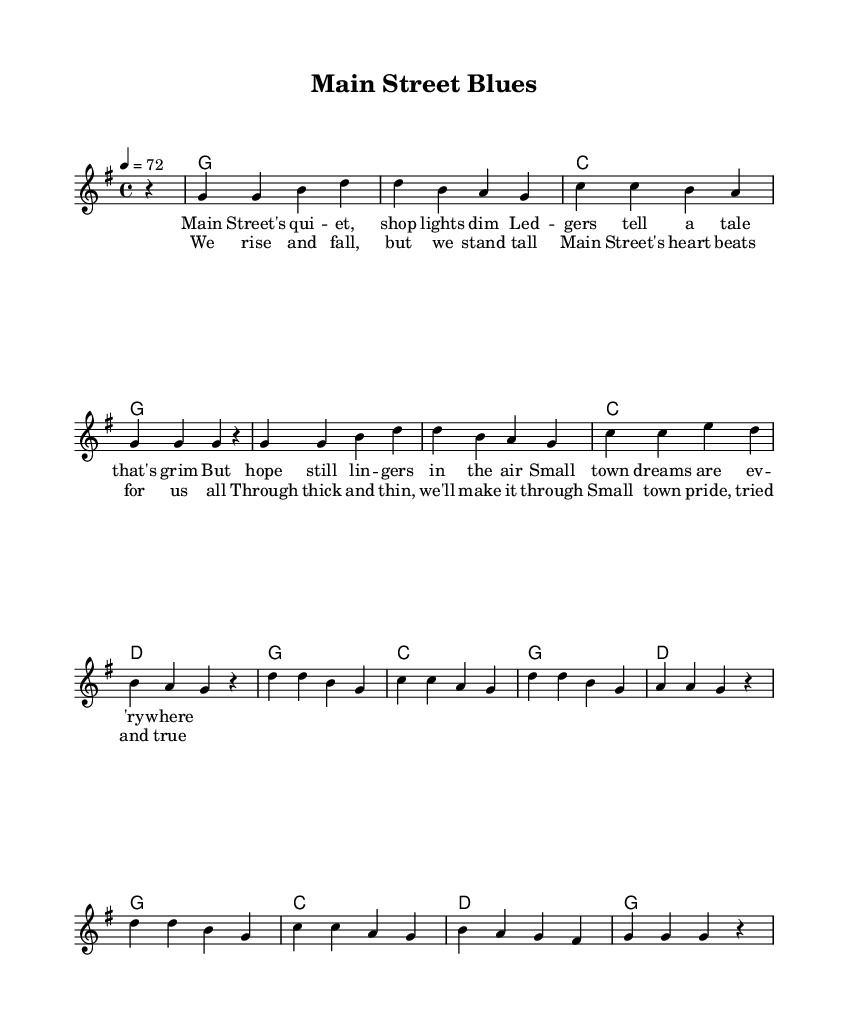What is the key signature of this music? The key signature of the music is G major, which has one sharp (F#). This can be determined by looking at the key indication at the beginning of the score.
Answer: G major What is the time signature of this music? The time signature is four-four, indicated by "4/4" at the beginning of the piece. This means there are four beats in each measure.
Answer: Four-four What is the tempo marking of the music? The tempo marking is quarter note equals 72, shown at the beginning of the score as "4 = 72." This indication tells the performer the pace at which to play the piece.
Answer: Quarter note equals 72 Which section features the lyrics about small-town pride? The lyrics that reference small-town pride are found in the chorus, as they emphasize standing strong and being "tried and true."
Answer: Chorus How many measures are in the verse section? The verse section contains eight measures, which can be counted by looking at the notation within the verse lyrics.
Answer: Eight measures What do the lyrics of the chorus convey about the community? The lyrics of the chorus convey resilience and togetherness, highlighting that the community rises and falls together while maintaining pride.
Answer: Resilience and togetherness What musical form does the piece predominantly follow? The piece predominantly follows a verse-chorus structure, as indicated by the presence of distinct verse lyrics followed by a repeated chorus.
Answer: Verse-chorus structure 